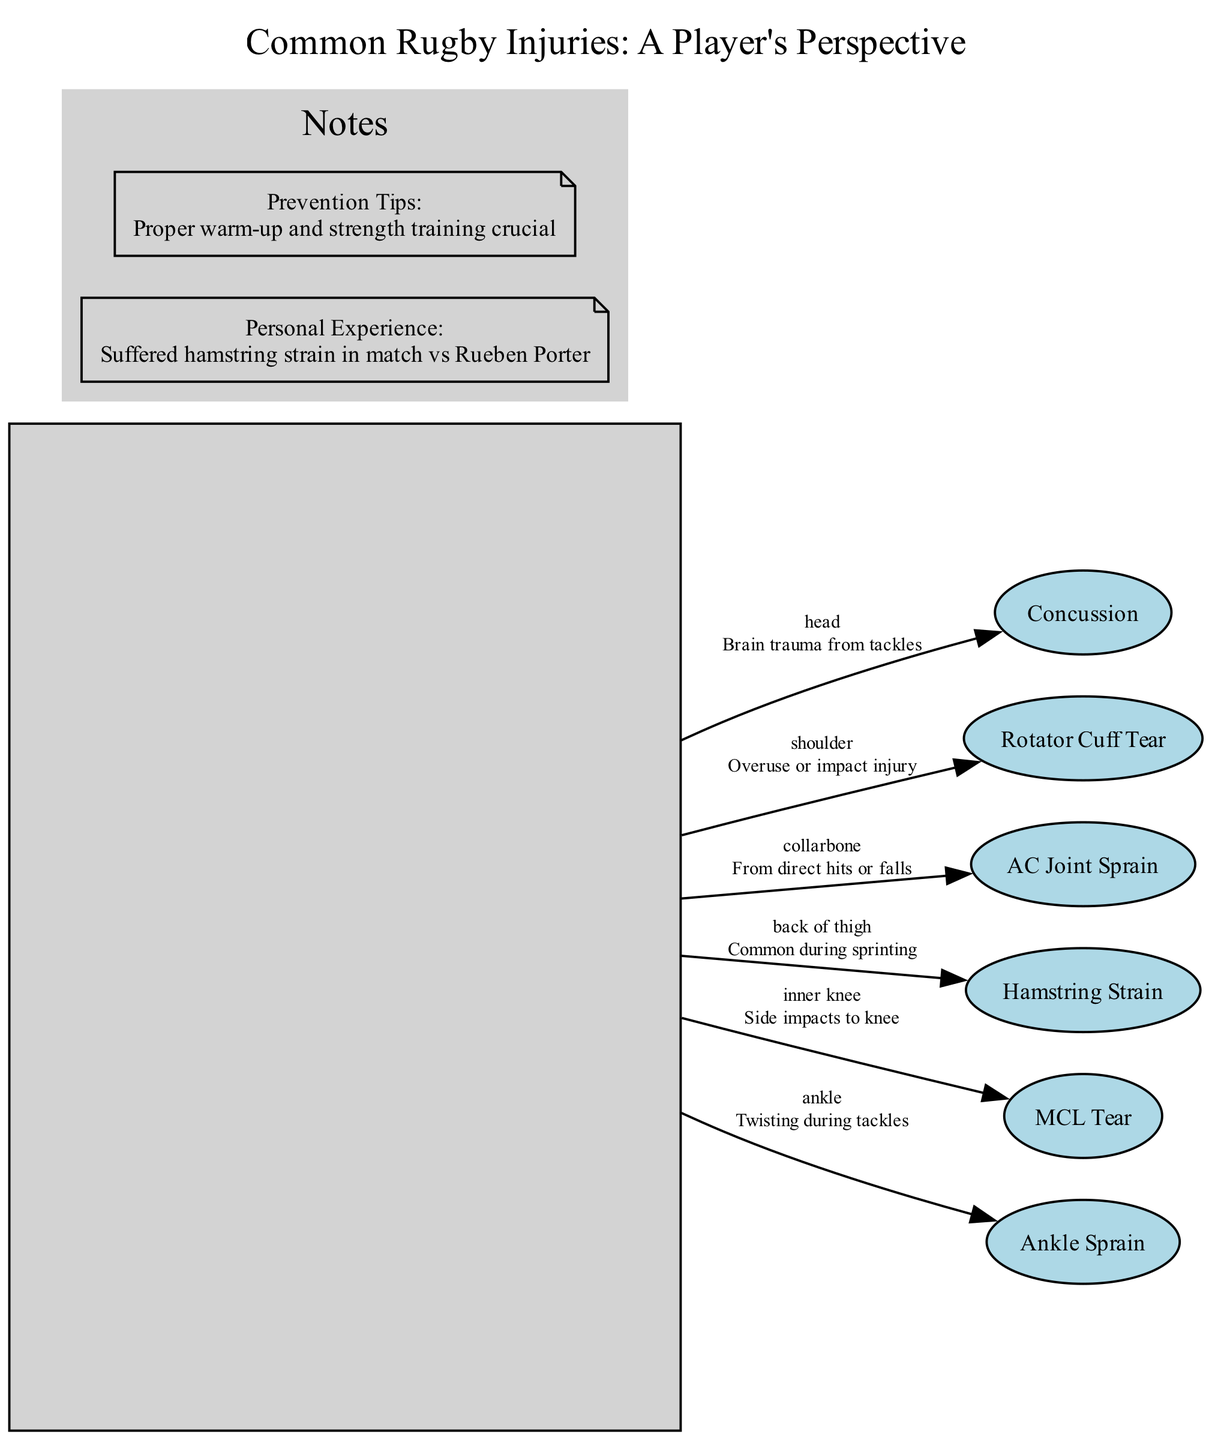What's the total number of injuries listed? The diagram lists six specific injuries, which can be counted directly from the listed injury nodes.
Answer: 6 What injury is associated with the collarbone? The diagram indicates that the injury associated with the collarbone is an AC Joint Sprain, which is specified directly.
Answer: AC Joint Sprain Which injury is located in the back of the thigh? The diagram shows that the Hamstring Strain is located in the back of the thigh, as mentioned in its description.
Answer: Hamstring Strain What type of injury occurs from twisting during tackles? The diagram describes that an Ankle Sprain occurs from twisting during tackles, as explicitly stated.
Answer: Ankle Sprain Which injury has the description of "Brain trauma from tackles"? The diagram clearly states that Concussion is described as "Brain trauma from tackles", making it identifiable directly from the text.
Answer: Concussion How many side notes are included in the diagram? The diagram contains two side notes, which can be counted from the note nodes labelled within the cluster 'Notes'.
Answer: 2 What is highlighted in the Prevention Tips note? The Prevention Tips note highlights that proper warm-up and strength training are crucial, as stated directly within the note content.
Answer: Proper warm-up and strength training crucial Which injury results from side impacts to the knee? The MCL Tear injury is specified as resulting from side impacts to the knee, which can be seen from the description attached to MCL Tear in the diagram.
Answer: MCL Tear What is the location of the Rotator Cuff Tear? The diagram specifies that the Rotator Cuff Tear is located in the shoulder, as indicated in its position and description.
Answer: Shoulder 